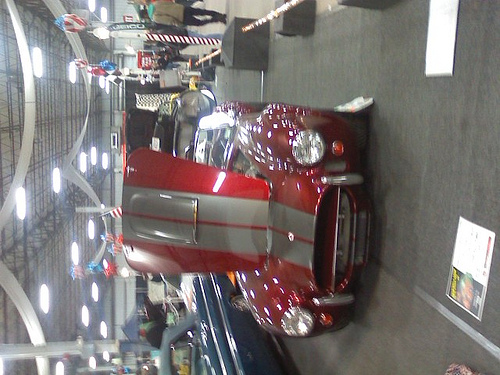<image>
Can you confirm if the car is to the right of the man? No. The car is not to the right of the man. The horizontal positioning shows a different relationship. 